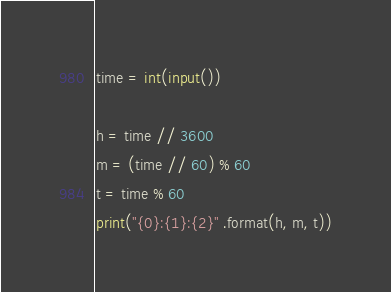Convert code to text. <code><loc_0><loc_0><loc_500><loc_500><_Python_>time = int(input())

h = time // 3600
m = (time // 60) % 60
t = time % 60
print("{0}:{1}:{2}" .format(h, m, t))</code> 